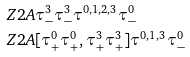Convert formula to latex. <formula><loc_0><loc_0><loc_500><loc_500>& Z 2 A \tau ^ { 3 } _ { - } \tau ^ { 3 } _ { - } \tau ^ { 0 , 1 , 2 , 3 } \tau ^ { 0 } _ { - } \\ & Z 2 A [ \tau ^ { 0 } _ { + } \tau ^ { 0 } _ { + } , \tau ^ { 3 } _ { + } \tau ^ { 3 } _ { + } ] \tau ^ { 0 , 1 , 3 } \tau ^ { 0 } _ { - }</formula> 